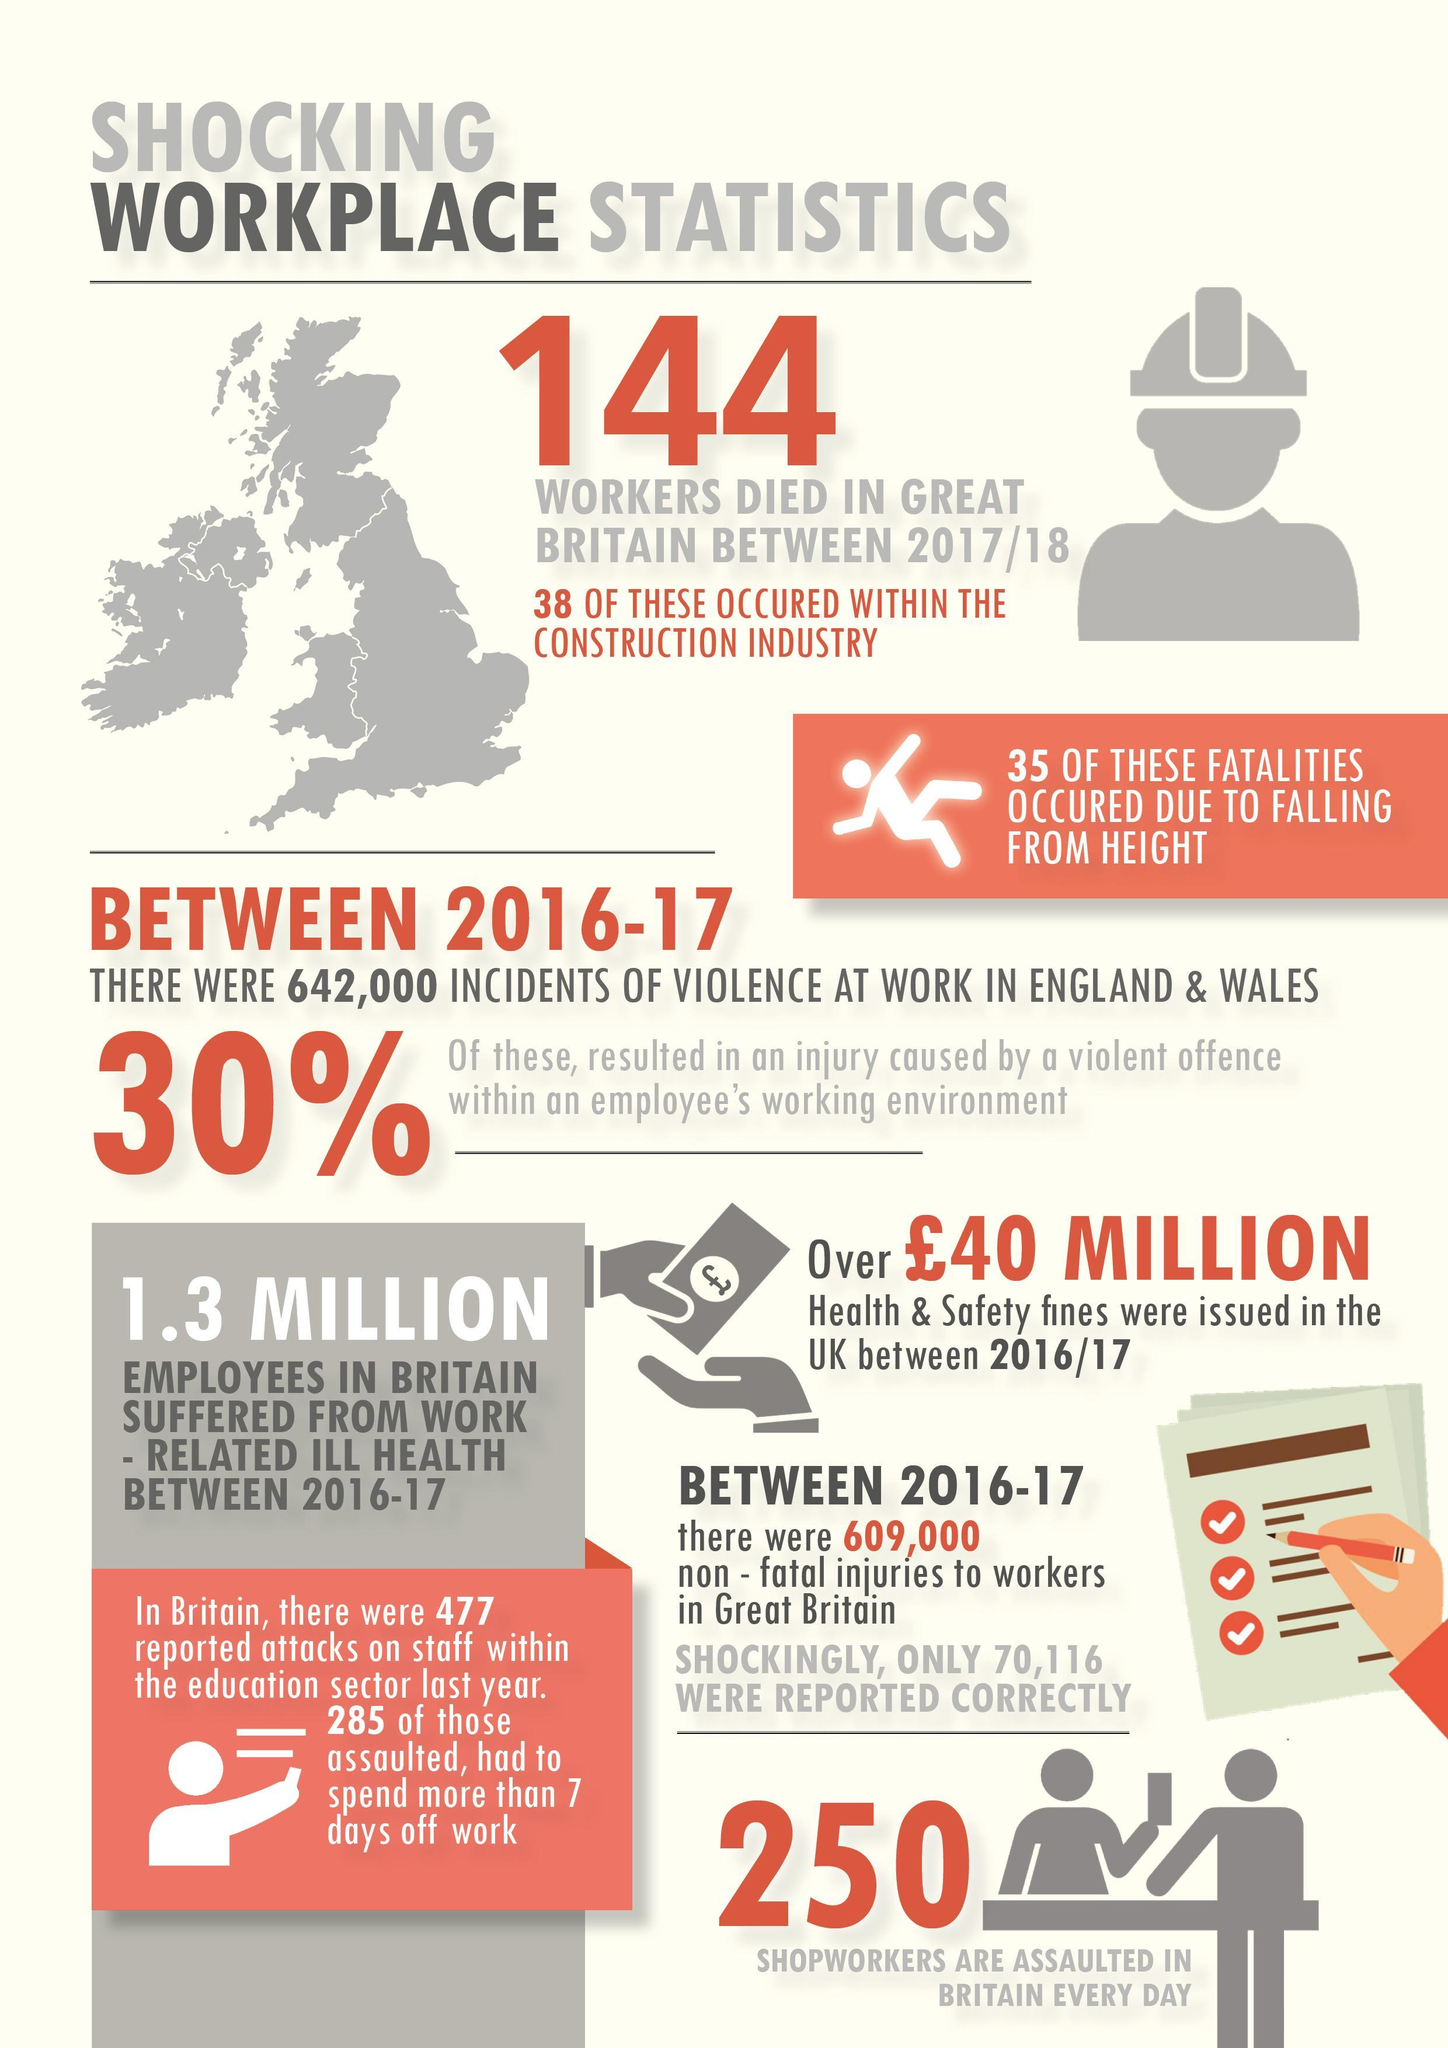What percent of workers died in Great Britain between 2017/18 within the construction industry?
Answer the question with a short phrase. 26.38% 